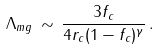Convert formula to latex. <formula><loc_0><loc_0><loc_500><loc_500>\Lambda _ { m g } \, \sim \, \frac { 3 f _ { c } } { 4 r _ { c } ( 1 - f _ { c } ) ^ { \gamma } } \, .</formula> 